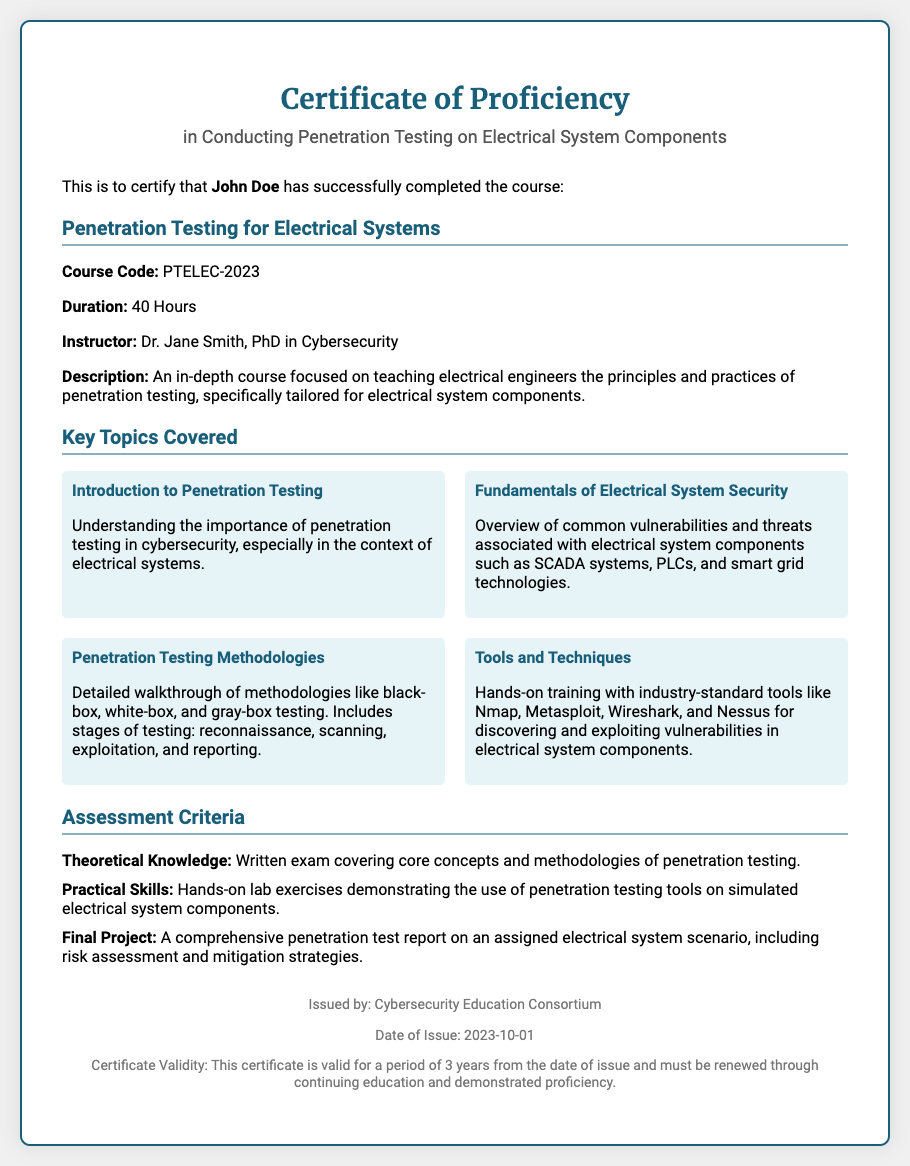What is the title of the course? The title of the course is mentioned in the document as "Penetration Testing for Electrical Systems."
Answer: Penetration Testing for Electrical Systems Who is the instructor of the course? The instructor's name is provided in the document as "Dr. Jane Smith, PhD in Cybersecurity."
Answer: Dr. Jane Smith What is the duration of the course? The document specifies the duration of the course as "40 Hours."
Answer: 40 Hours What is the course code? The course code for this training is stated in the document as "PTELEC-2023."
Answer: PTELEC-2023 What organization issued the certificate? The issuing organization is listed in the document as "Cybersecurity Education Consortium."
Answer: Cybersecurity Education Consortium What are the key topics covered in the course? The document lists several key topics including "Introduction to Penetration Testing" and "Tools and Techniques," among others.
Answer: Introduction to Penetration Testing, Tools and Techniques What is the certificate validity period? The document states that the certificate is valid for a period of "3 years" from the date of issue.
Answer: 3 years What is the final project requirement? The final project requirement includes "A comprehensive penetration test report on an assigned electrical system scenario."
Answer: A comprehensive penetration test report What date was the certificate issued? The document specifies the date of issue as "2023-10-01."
Answer: 2023-10-01 